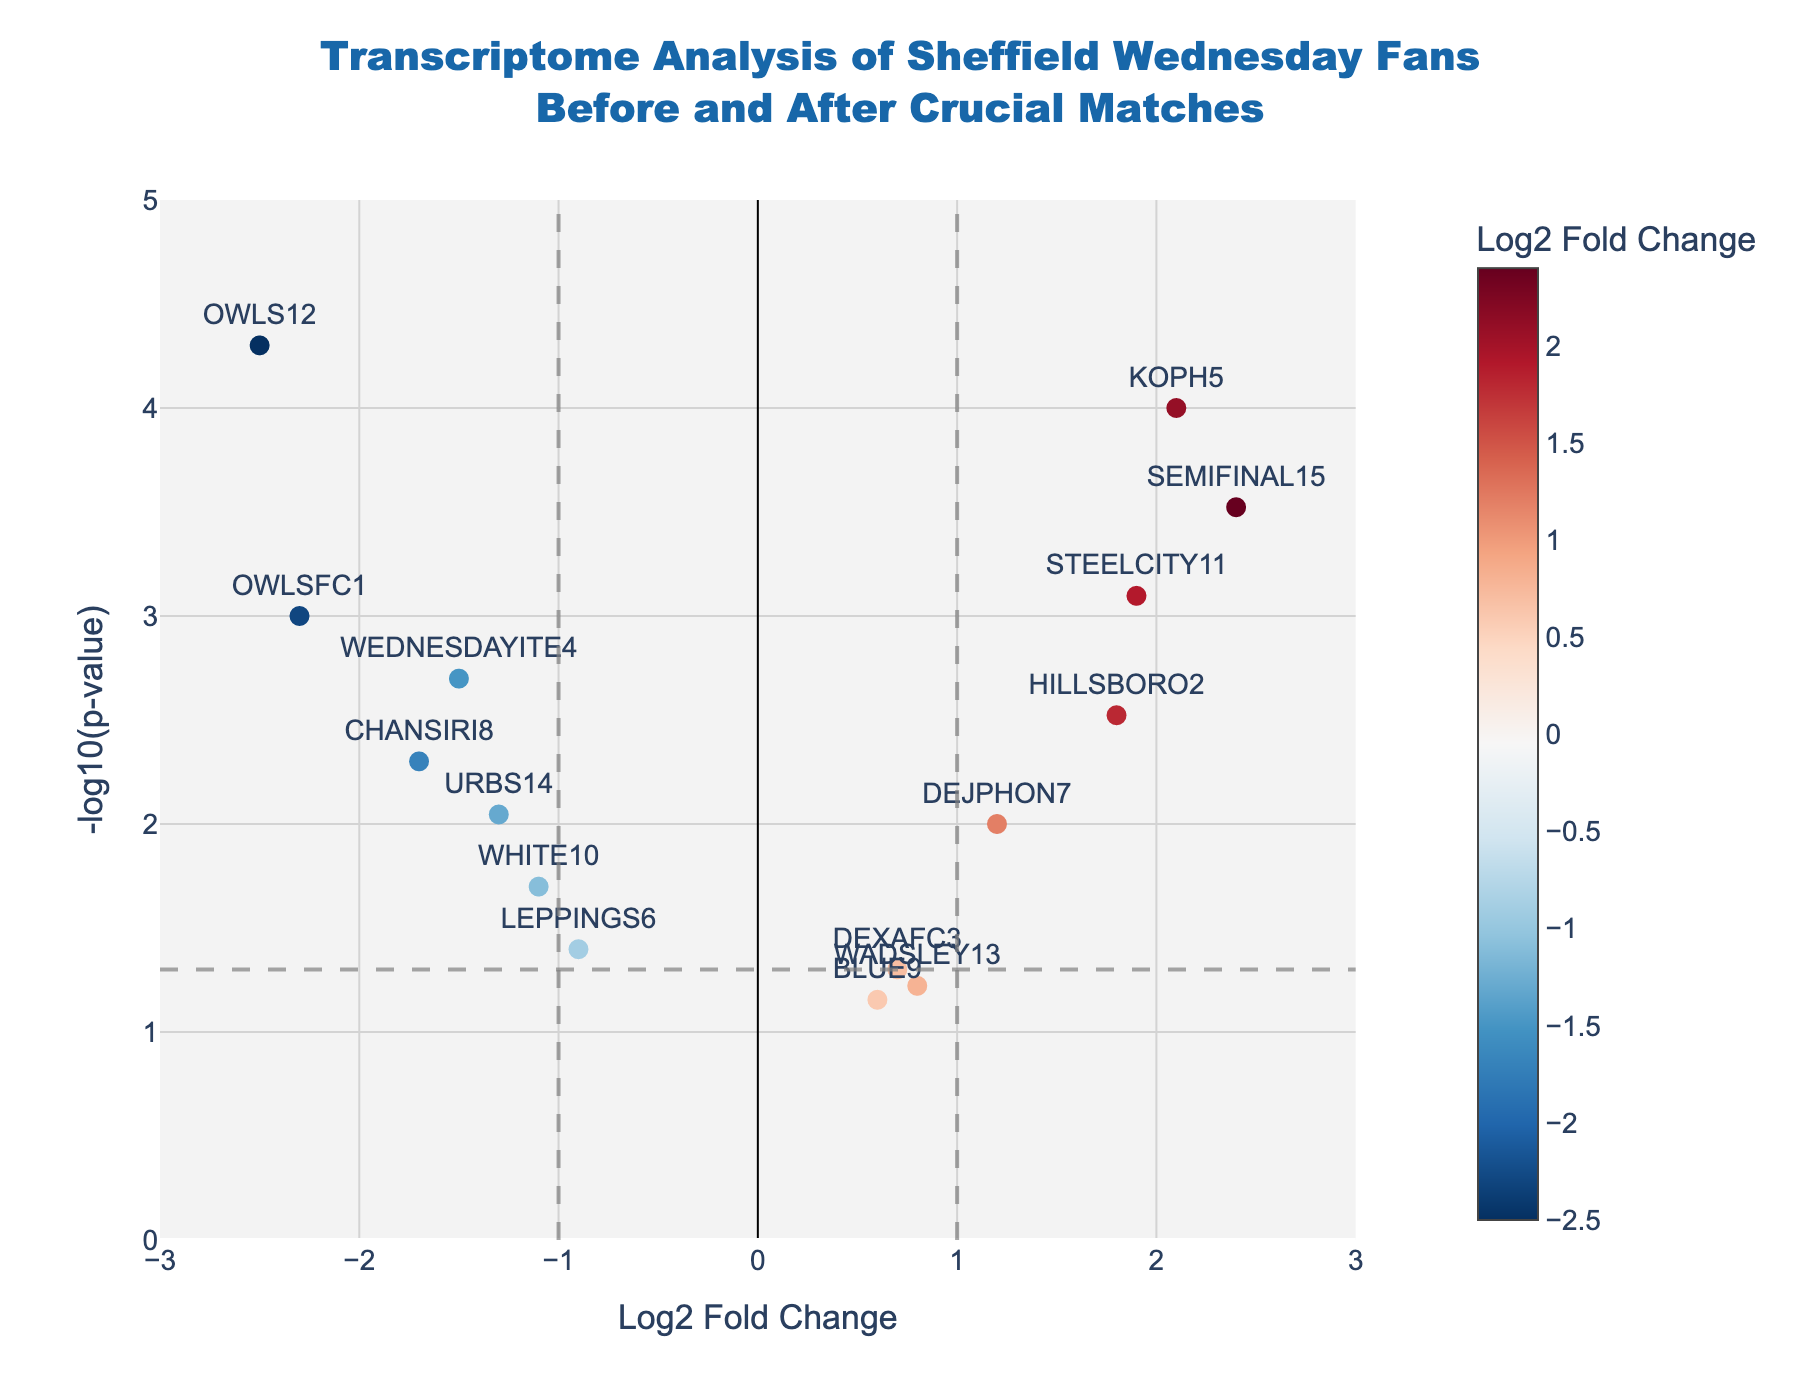Which gene has the highest -log10(p-value) in the plot? Look at the y-axis and find the point with the highest value. The gene at this point is labeled "OWLS12".
Answer: OWLS12 Which gene has the highest Log2 Fold Change? Observe the gene plotted furthest to the right on the x-axis, labeled "SEMIFINAL15".
Answer: SEMIFINAL15 What's the title of the plot? The title is displayed at the top center of the plot: "Transcriptome Analysis of Sheffield Wednesday Fans Before and After Crucial Matches".
Answer: Transcriptome Analysis of Sheffield Wednesday Fans Before and After Crucial Matches How many points have a Log2 Fold Change greater than 1? Count the data points on the right side of the vertical line at x=1. There are four points: SEMIFINAL15, STEELCITY11, KOPH5, and HILLSBORO2.
Answer: 4 Which gene has the lowest Log2 Fold Change but a significant p-value (below 0.05)? Find the point furthest to the left on the x-axis and below the horizontal dashed line at y=-log10(0.05). The gene is "OWLS12".
Answer: OWLS12 Which genes have a negative Log2 Fold Change but a highly significant p-value (below 0.01)? Look for points to the left of the origin and below the horizontal threshold line corresponding to y=-log10(0.01). The genes are "OWLS12", "OWLSFC1", "WEDNESDAYITE4", "CHANSIRI8", and "URBS14".
Answer: OWLS12, OWLSFC1, WEDNESDAYITE4, CHANSIRI8, URBS14 What is the Log2 Fold Change and p-value of the gene "KOPH5"? Identify the text label "KOPH5" in the plot and refer to its hover text: "Log2FC: 2.10", "p-value: 0.0001".
Answer: Log2FC: 2.10, p-value: 0.0001 Which gene is located closest to the horizontal threshold line? Locate the point nearest to the horizontal dashed line, representing y=-log10(0.05). The gene is "LEPPINGS6".
Answer: LEPPINGS6 What are the gene names of data points that have a Log2 Fold Change between -1 and 1, and a p-value below 0.05? Identify the points within the vertical lines at x=-1 and x=1, and below the horizontal dashed line, the corresponding genes are "DEJPHON7" and "WHITE10".
Answer: DEJPHON7, WHITE10 